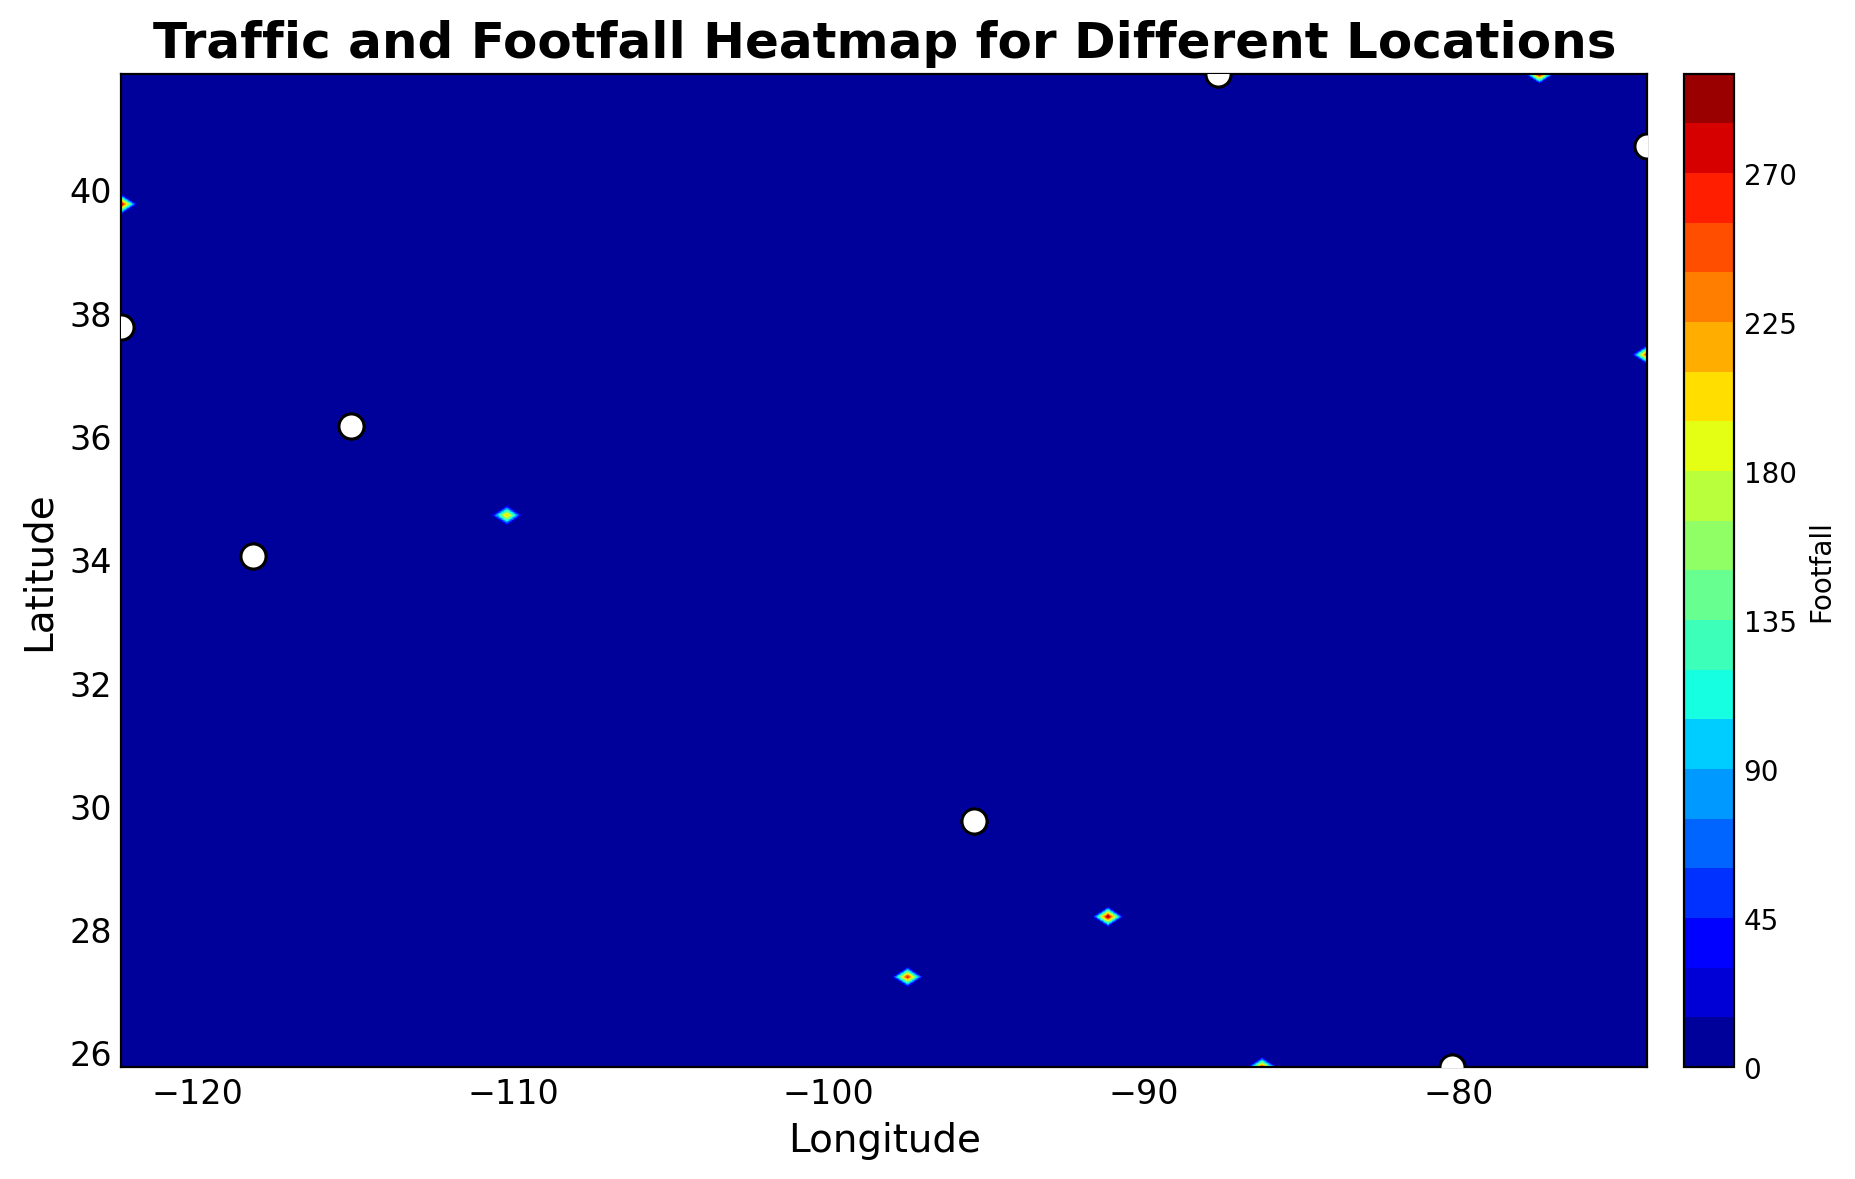What's the footfall like at the peak times in New York? To determine the peak times in New York, observe when the footfall reaches its highest values on the heatmap. The contour plot will show the highest footfall around 18:00.
Answer: 300 Which city has the highest footfall between 14:00 and 16:00? Compare the footfalls of different cities at the 14:00 and 16:00 intervals on the heatmap. The plot will indicate that New York has one of the higher values, reaching 250 at 14:00 and 280 at 16:00.
Answer: New York What is the trend of footfall in Los Angeles throughout the day? Observe the heatmap contour levels specifically over Los Angeles coordinates as time progresses. Notice how the footfall increases from morning (10:00) to evening (18:00).
Answer: Increasing Does Miami have higher footfall than Houston at any time of the day? Compare the contour levels over Miami and Houston. Miami’s values tend to be higher, especially peaking towards the end of the day.
Answer: Yes Which city shows the least footfall at 10:00? Look at the contour plot for each city at the 10:00 time slot, noting the contour level. Houston and Los Angeles are likely contenders for the lowest levels, but Houston appears to have the lowest value.
Answer: Houston How does the footfall in Chicago at 12:00 compare to that in San Francisco at 14:00? Analyze the contour levels for Chicago at 12:00 and San Francisco at 14:00. Chicago at 12:00 shows a footfall around 210, while San Francisco at 14:00 has a footfall around 210.
Answer: Equal What time of day tends to have the highest footfall across all cities? This involves scanning the contour plot for the highest levels across different times for all cities. The consistently higher footfalls tend to appear around 18:00.
Answer: 18:00 Is there any city where footfall does not increase throughout the day? Checking the contour plot for each city, you'll notice that every city shows increasing footfall trends towards the evening, with none showing a constant or decreasing trend.
Answer: No What's the average footfall in San Francisco at 12:00 and 14:00? Locate the footfall for San Francisco at 12:00 (180) and at 14:00 (210). Calculate the average: (180 + 210) / 2 = 195
Answer: 195 